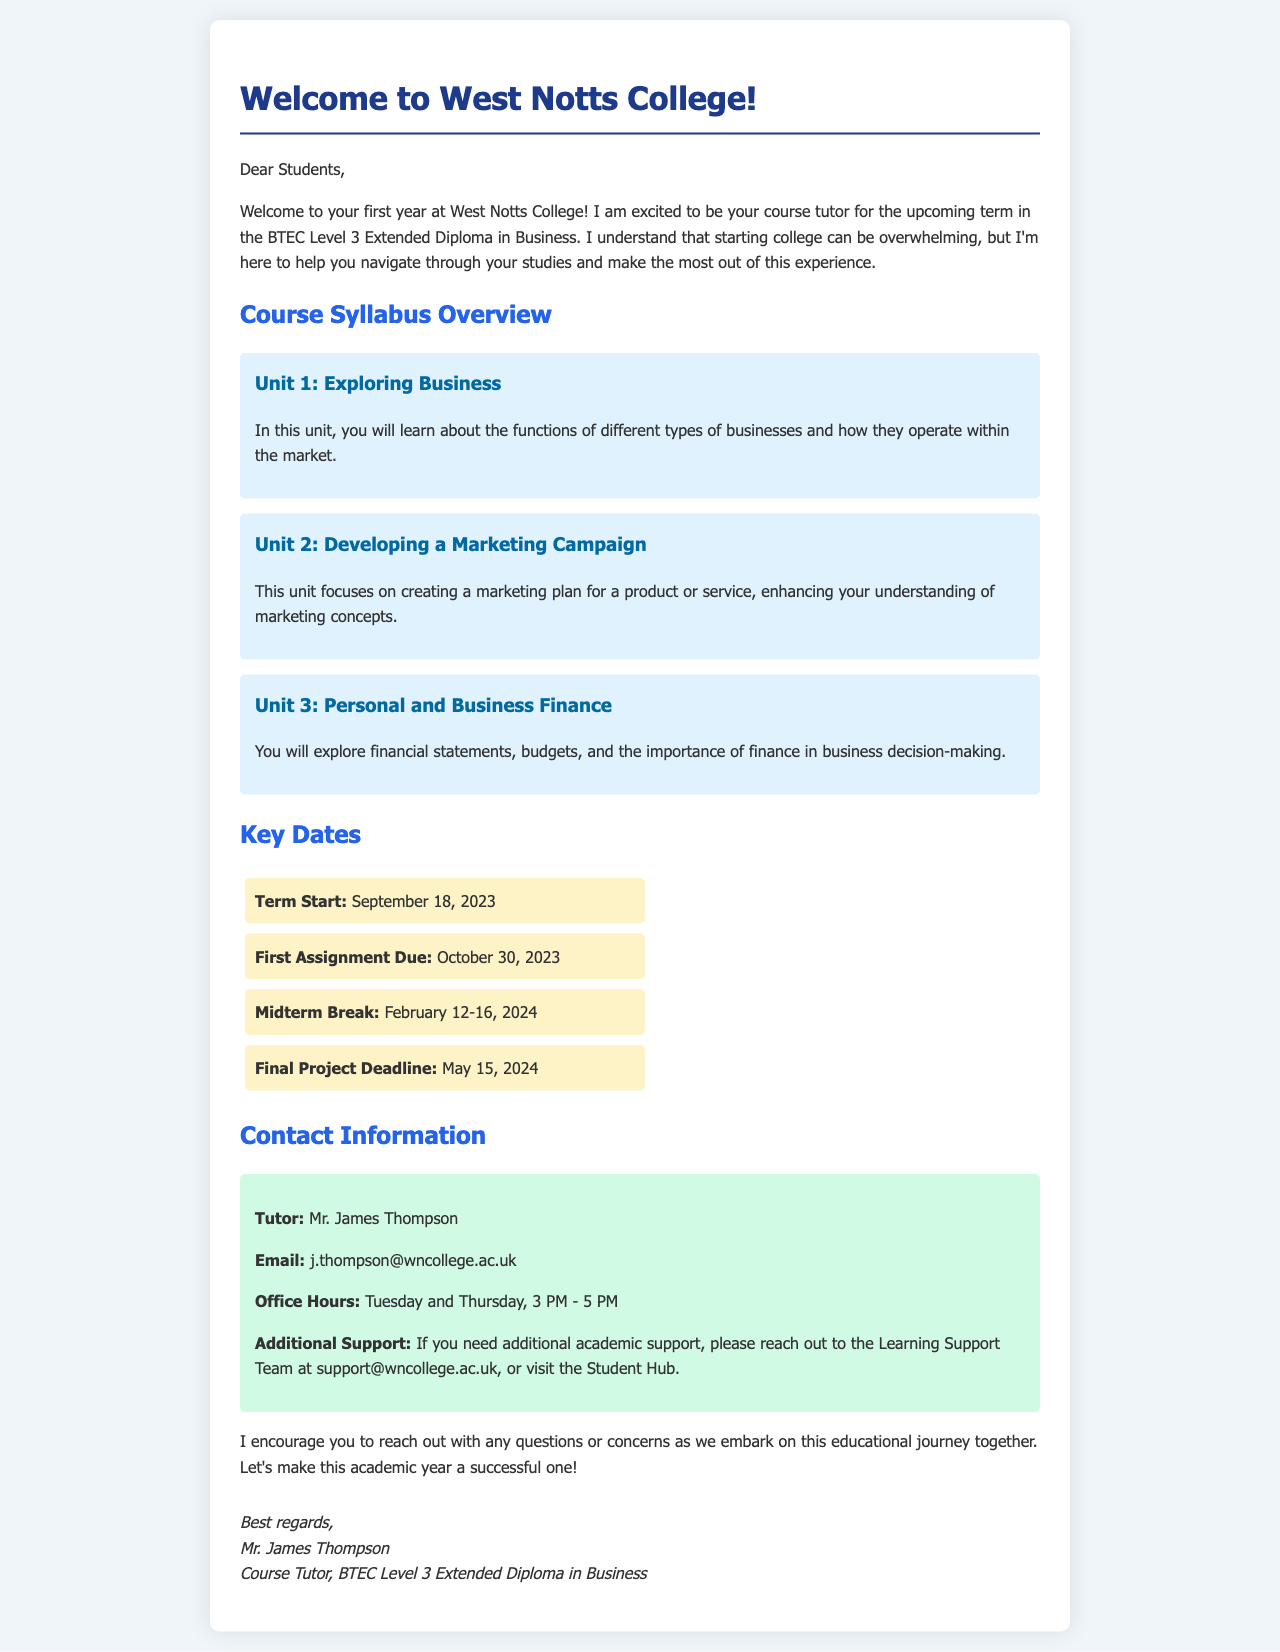What is the course name? The course name is provided in the introduction of the document as "BTEC Level 3 Extended Diploma in Business."
Answer: BTEC Level 3 Extended Diploma in Business Who is the course tutor? The course tutor's name is stated in the signature of the letter as "Mr. James Thompson."
Answer: Mr. James Thompson What is the date of the first assignment due? The document lists October 30, 2023 as the due date for the first assignment under the key dates section.
Answer: October 30, 2023 When does the term start? The start date of the term is specified in the key dates section as September 18, 2023.
Answer: September 18, 2023 What is the office hours for the tutor? The office hours are provided in the contact information as "Tuesday and Thursday, 3 PM - 5 PM."
Answer: Tuesday and Thursday, 3 PM - 5 PM What unit involves marketing? The unit focusing on marketing is mentioned as "Unit 2: Developing a Marketing Campaign" in the syllabus overview.
Answer: Unit 2: Developing a Marketing Campaign What should students do if they need additional academic support? The document suggests reaching out to the Learning Support Team via a specified email or visiting the Student Hub for additional academic support.
Answer: support@wncollege.ac.uk What is the deadline for the final project? The final project deadline is clearly stated in the key dates section as May 15, 2024.
Answer: May 15, 2024 What kind of document is this? The structure and content suggest that this is a welcome letter from a course tutor to students.
Answer: Welcome letter 